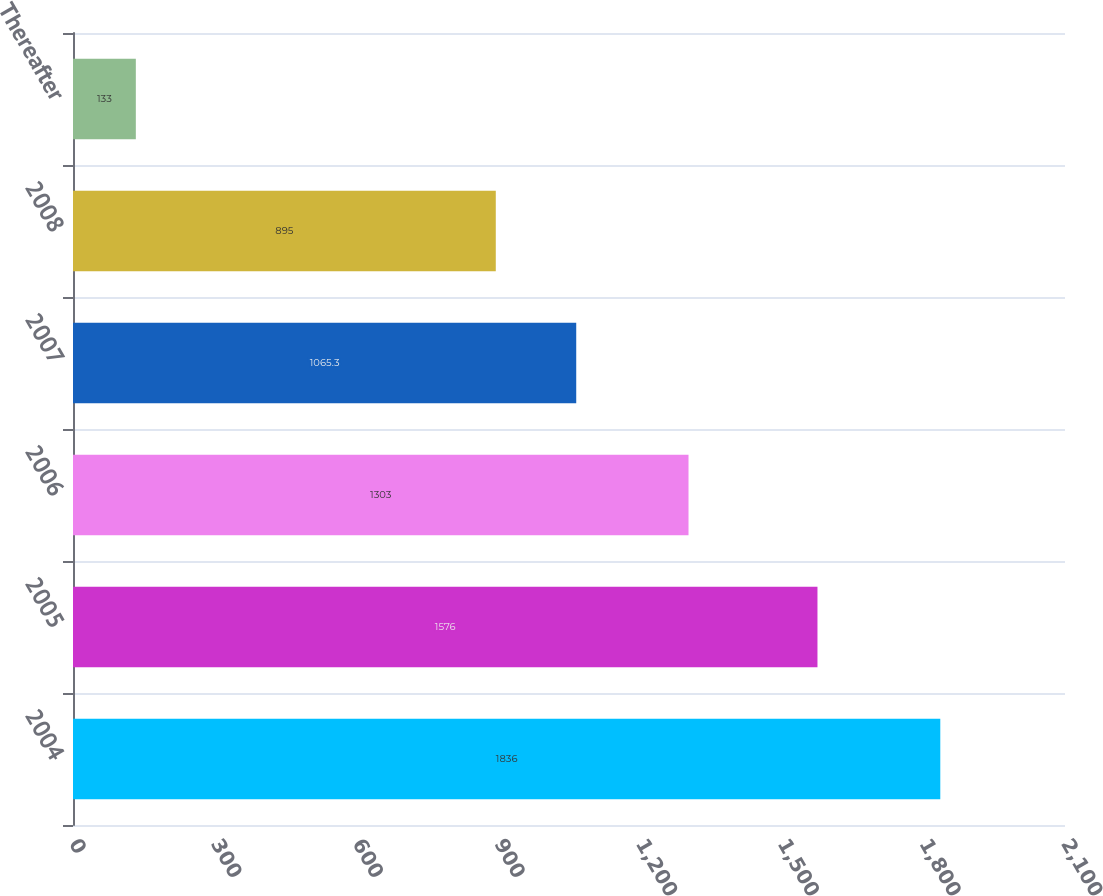Convert chart. <chart><loc_0><loc_0><loc_500><loc_500><bar_chart><fcel>2004<fcel>2005<fcel>2006<fcel>2007<fcel>2008<fcel>Thereafter<nl><fcel>1836<fcel>1576<fcel>1303<fcel>1065.3<fcel>895<fcel>133<nl></chart> 